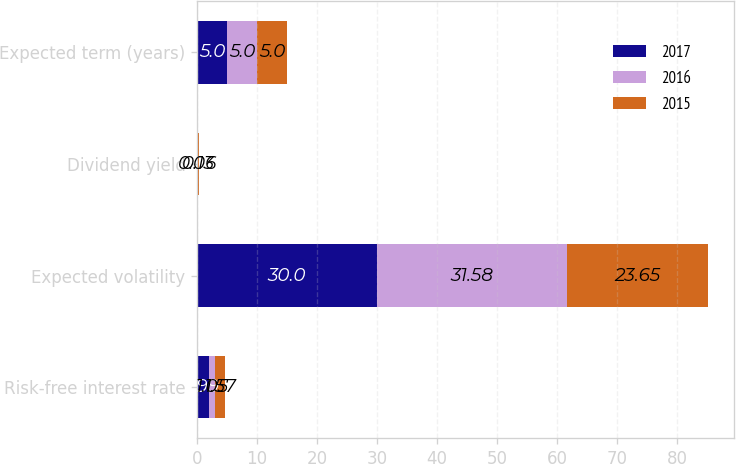Convert chart to OTSL. <chart><loc_0><loc_0><loc_500><loc_500><stacked_bar_chart><ecel><fcel>Risk-free interest rate<fcel>Expected volatility<fcel>Dividend yield<fcel>Expected term (years)<nl><fcel>2017<fcel>1.99<fcel>30<fcel>0.06<fcel>5<nl><fcel>2016<fcel>1.05<fcel>31.58<fcel>0.06<fcel>5<nl><fcel>2015<fcel>1.57<fcel>23.65<fcel>0.13<fcel>5<nl></chart> 